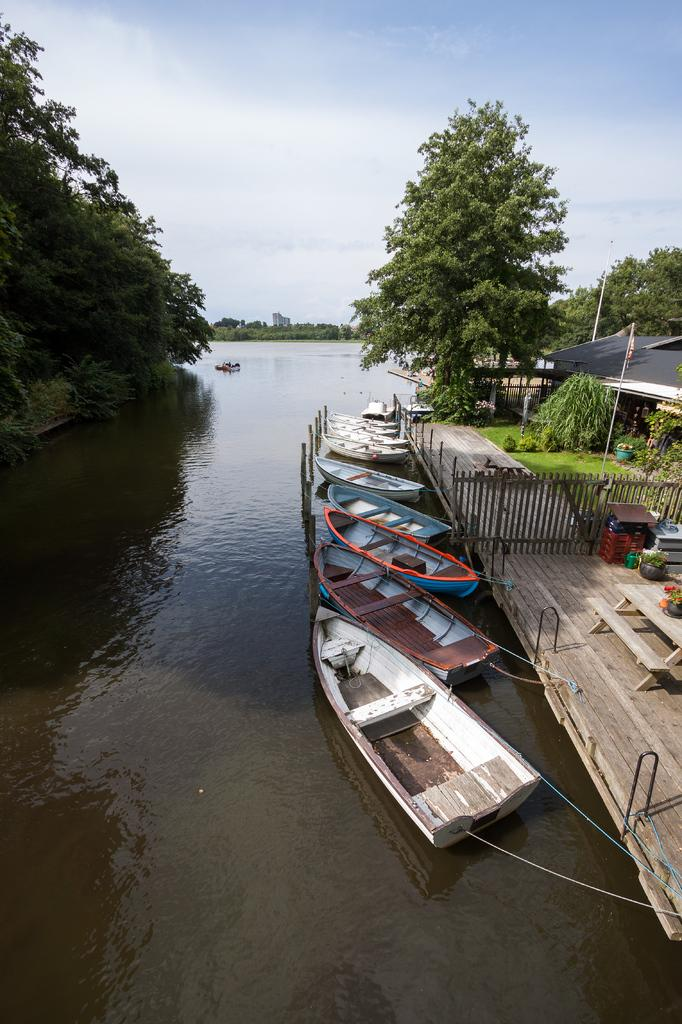What type of vehicles can be seen in the image? There are boats in the image. What type of natural elements are present in the image? There are trees and water visible in the image. What type of structures can be seen in the image? There are poles, tents, and tables in the image. What type of barrier is present in the image? There is fencing in the image. What type of surface is visible in the image? There are objects on a wooden floor in the image. What is the color of the sky in the image? The sky is blue and white in color. How many women are smashing screws in the image? There are no women or screws present in the image. What type of tool is being used to smash the screws in the image? There is no tool or screws being smashed in the image. 